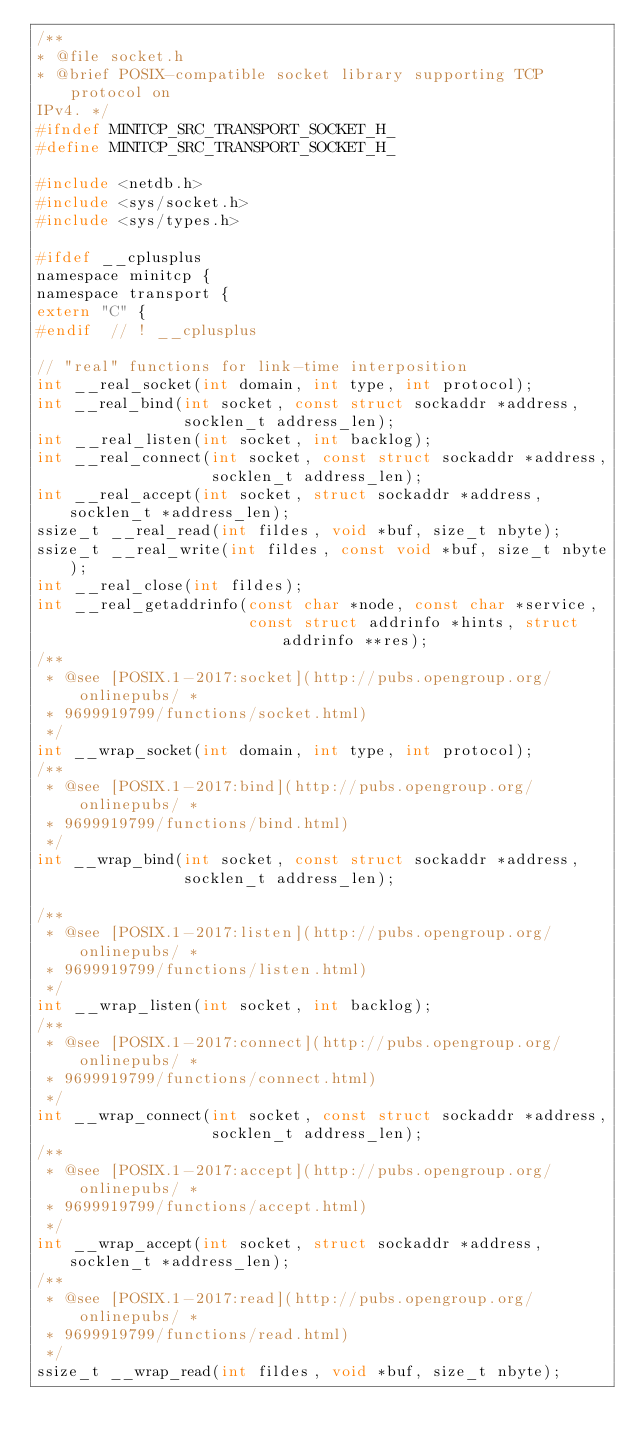Convert code to text. <code><loc_0><loc_0><loc_500><loc_500><_C_>/**
* @file socket.h
* @brief POSIX-compatible socket library supporting TCP protocol on
IPv4. */
#ifndef MINITCP_SRC_TRANSPORT_SOCKET_H_
#define MINITCP_SRC_TRANSPORT_SOCKET_H_

#include <netdb.h>
#include <sys/socket.h>
#include <sys/types.h>

#ifdef __cplusplus
namespace minitcp {
namespace transport {
extern "C" {
#endif  // ! __cplusplus

// "real" functions for link-time interposition
int __real_socket(int domain, int type, int protocol);
int __real_bind(int socket, const struct sockaddr *address,
                socklen_t address_len);
int __real_listen(int socket, int backlog);
int __real_connect(int socket, const struct sockaddr *address,
                   socklen_t address_len);
int __real_accept(int socket, struct sockaddr *address, socklen_t *address_len);
ssize_t __real_read(int fildes, void *buf, size_t nbyte);
ssize_t __real_write(int fildes, const void *buf, size_t nbyte);
int __real_close(int fildes);
int __real_getaddrinfo(const char *node, const char *service,
                       const struct addrinfo *hints, struct addrinfo **res);
/**
 * @see [POSIX.1-2017:socket](http://pubs.opengroup.org/onlinepubs/ *
 * 9699919799/functions/socket.html)
 */
int __wrap_socket(int domain, int type, int protocol);
/**
 * @see [POSIX.1-2017:bind](http://pubs.opengroup.org/onlinepubs/ *
 * 9699919799/functions/bind.html)
 */
int __wrap_bind(int socket, const struct sockaddr *address,
                socklen_t address_len);

/**
 * @see [POSIX.1-2017:listen](http://pubs.opengroup.org/onlinepubs/ *
 * 9699919799/functions/listen.html)
 */
int __wrap_listen(int socket, int backlog);
/**
 * @see [POSIX.1-2017:connect](http://pubs.opengroup.org/onlinepubs/ *
 * 9699919799/functions/connect.html)
 */
int __wrap_connect(int socket, const struct sockaddr *address,
                   socklen_t address_len);
/**
 * @see [POSIX.1-2017:accept](http://pubs.opengroup.org/onlinepubs/ *
 * 9699919799/functions/accept.html)
 */
int __wrap_accept(int socket, struct sockaddr *address, socklen_t *address_len);
/**
 * @see [POSIX.1-2017:read](http://pubs.opengroup.org/onlinepubs/ *
 * 9699919799/functions/read.html)
 */
ssize_t __wrap_read(int fildes, void *buf, size_t nbyte);</code> 